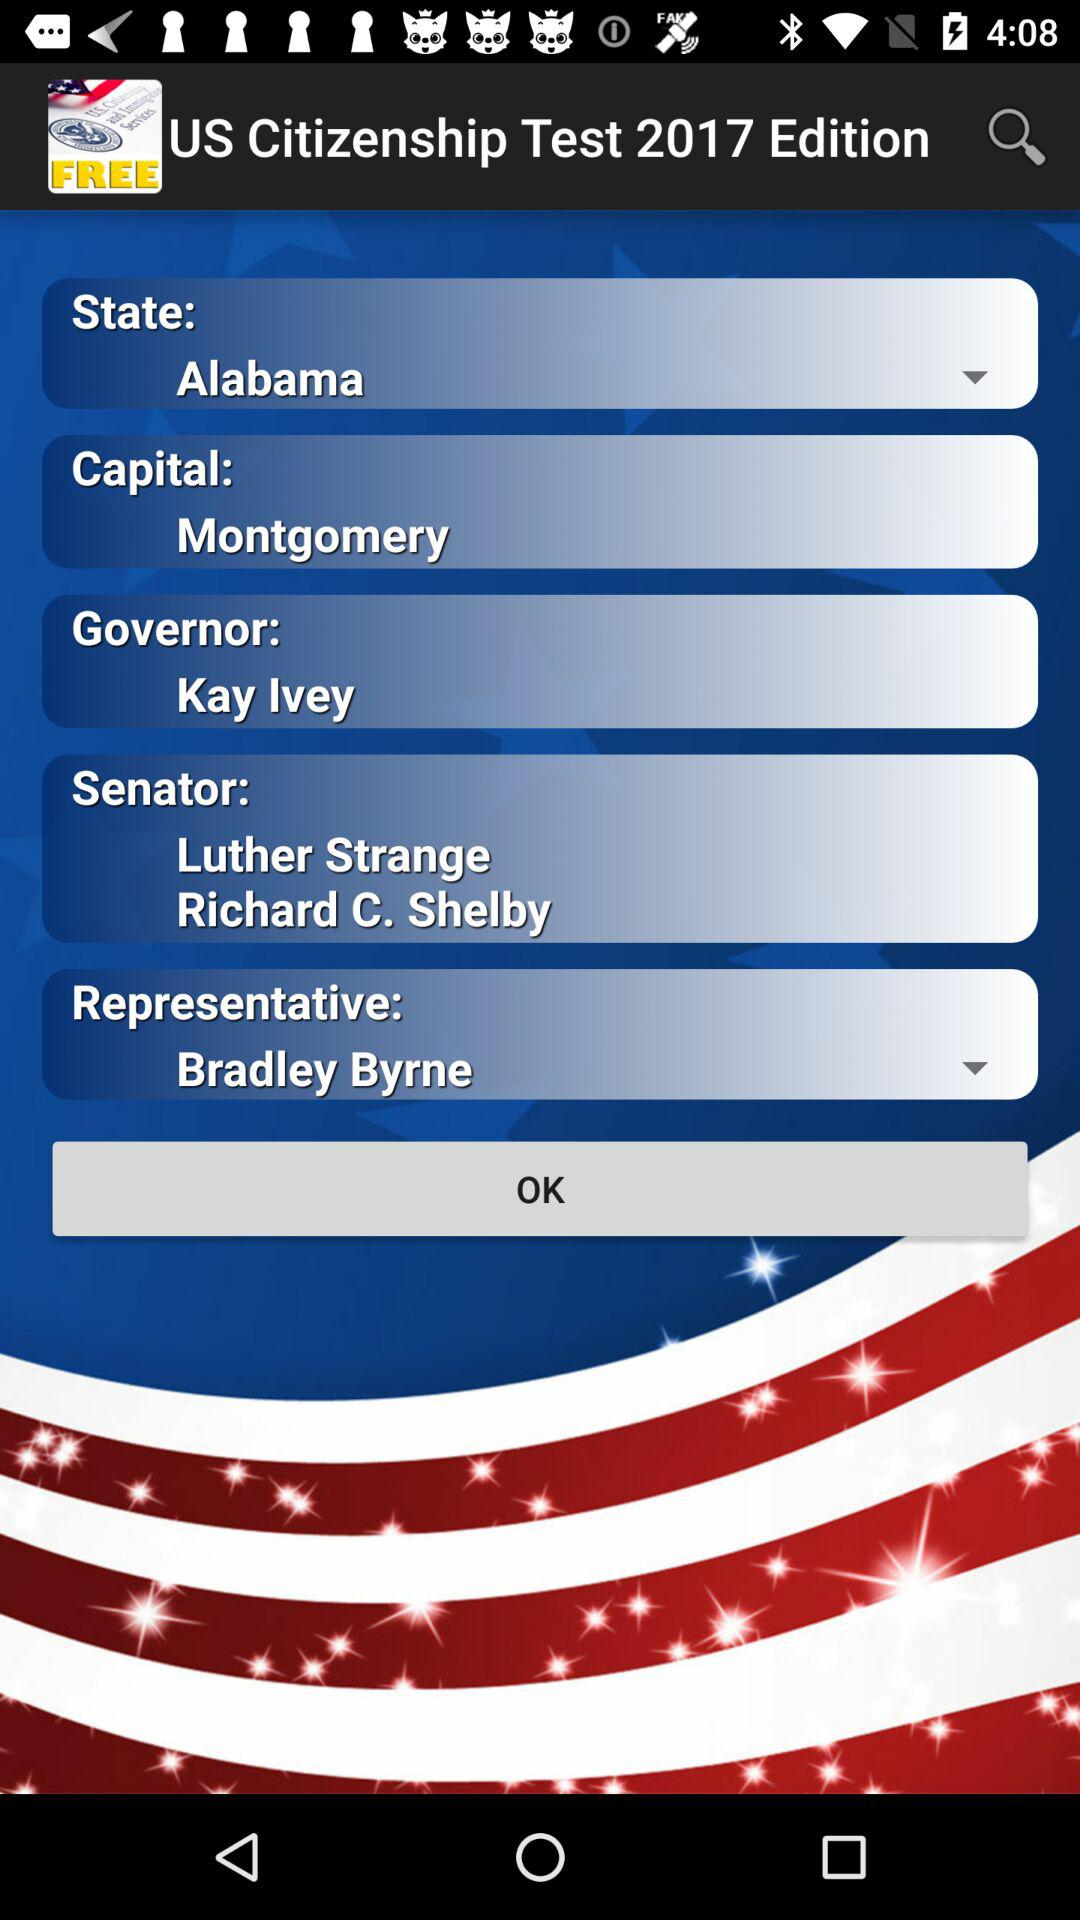What is the capital? The capital is Montgomery. 